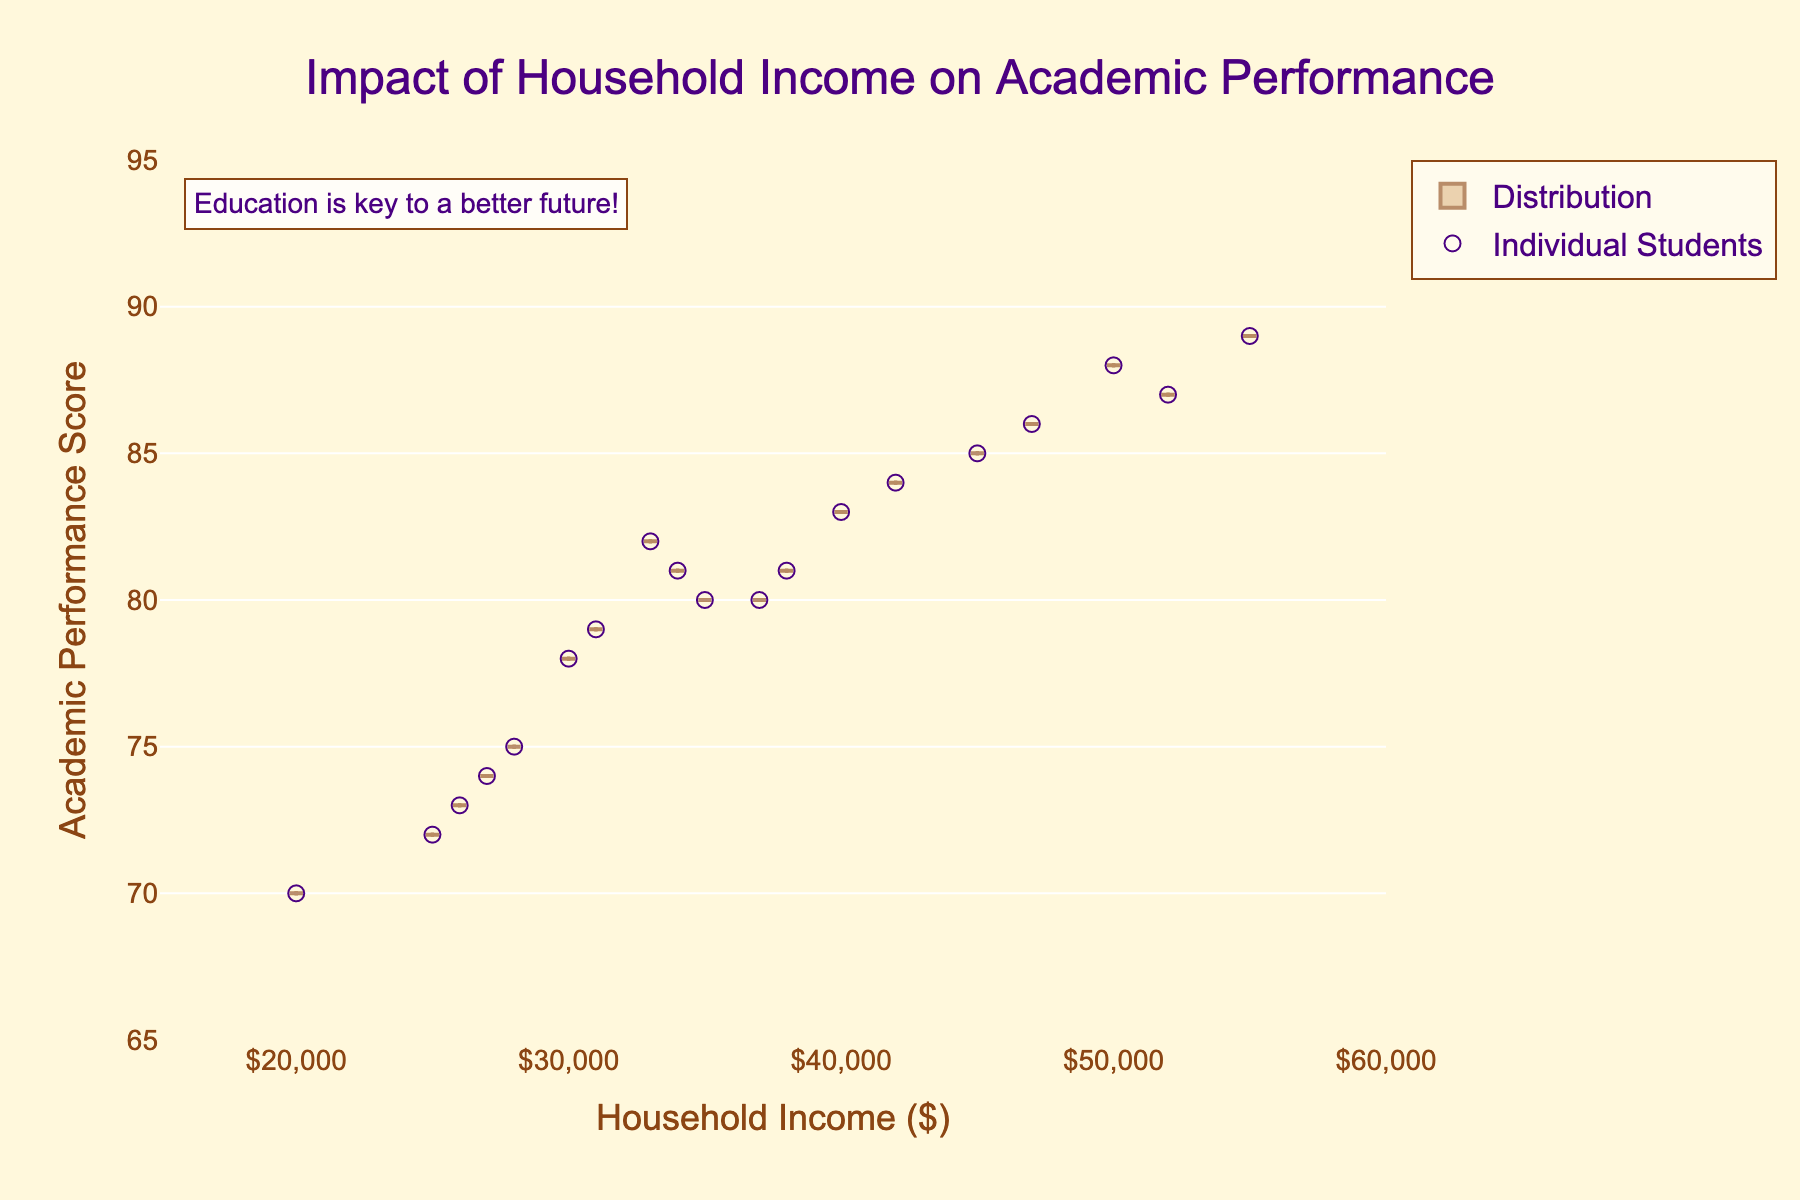What is the title of the figure? The title of the figure is centered at the top in larger font size and reads "Impact of Household Income on Academic Performance".
Answer: Impact of Household Income on Academic Performance What is the range of the y-axis? The y-axis range is labeled on the left of the chart. It starts from 65 and goes up to 95.
Answer: 65 to 95 How many individual student data points are there? Each blue circle on the scatter plot represents an individual student data point. By counting these points, we can see there are 19 students in total.
Answer: 19 Which household income level has the highest academic performance score? Looking at the scatter points, the highest academic performance score is located at a household income of $55,000 with an academic performance score of 89 (Mia).
Answer: $55,000 What is the mean academic performance score for all students in the chart? The meanline is displayed in the center of the violin plot. You can read the approximate value from this meanline, which is around 80.5.
Answer: 80.5 How does the academic performance score range of students from $20,000 household income compare with $50,000 household income? For $20,000, the performance score is around 70. For $50,000, it ranges from about 85 to 88. Clearly, $50,000 shows higher academic performance scores.
Answer: $50,000 shows higher scores What pattern can be observed between household income and academic performance? Observing the scatter points and the violin plot distribution, it generally appears that higher household income correlates with higher academic performance scores.
Answer: Higher income, higher performance Are there any students with the same academic performance scores? Checking the scatter points, we can see that there are several students with an academic performance score of 80.
Answer: Yes What is the lower threshold of the academic performance among students with a household income above $45,000? For household incomes above $45,000, the lowest academic performance score is 85 (Emily).
Answer: 85 Is there a clustered pattern of academic performances around a specific income range? Many data points are clustered around the $30,000 to $40,000 income range with academic performance scores ranging from 70 to 83.
Answer: $30,000 to $40,000 